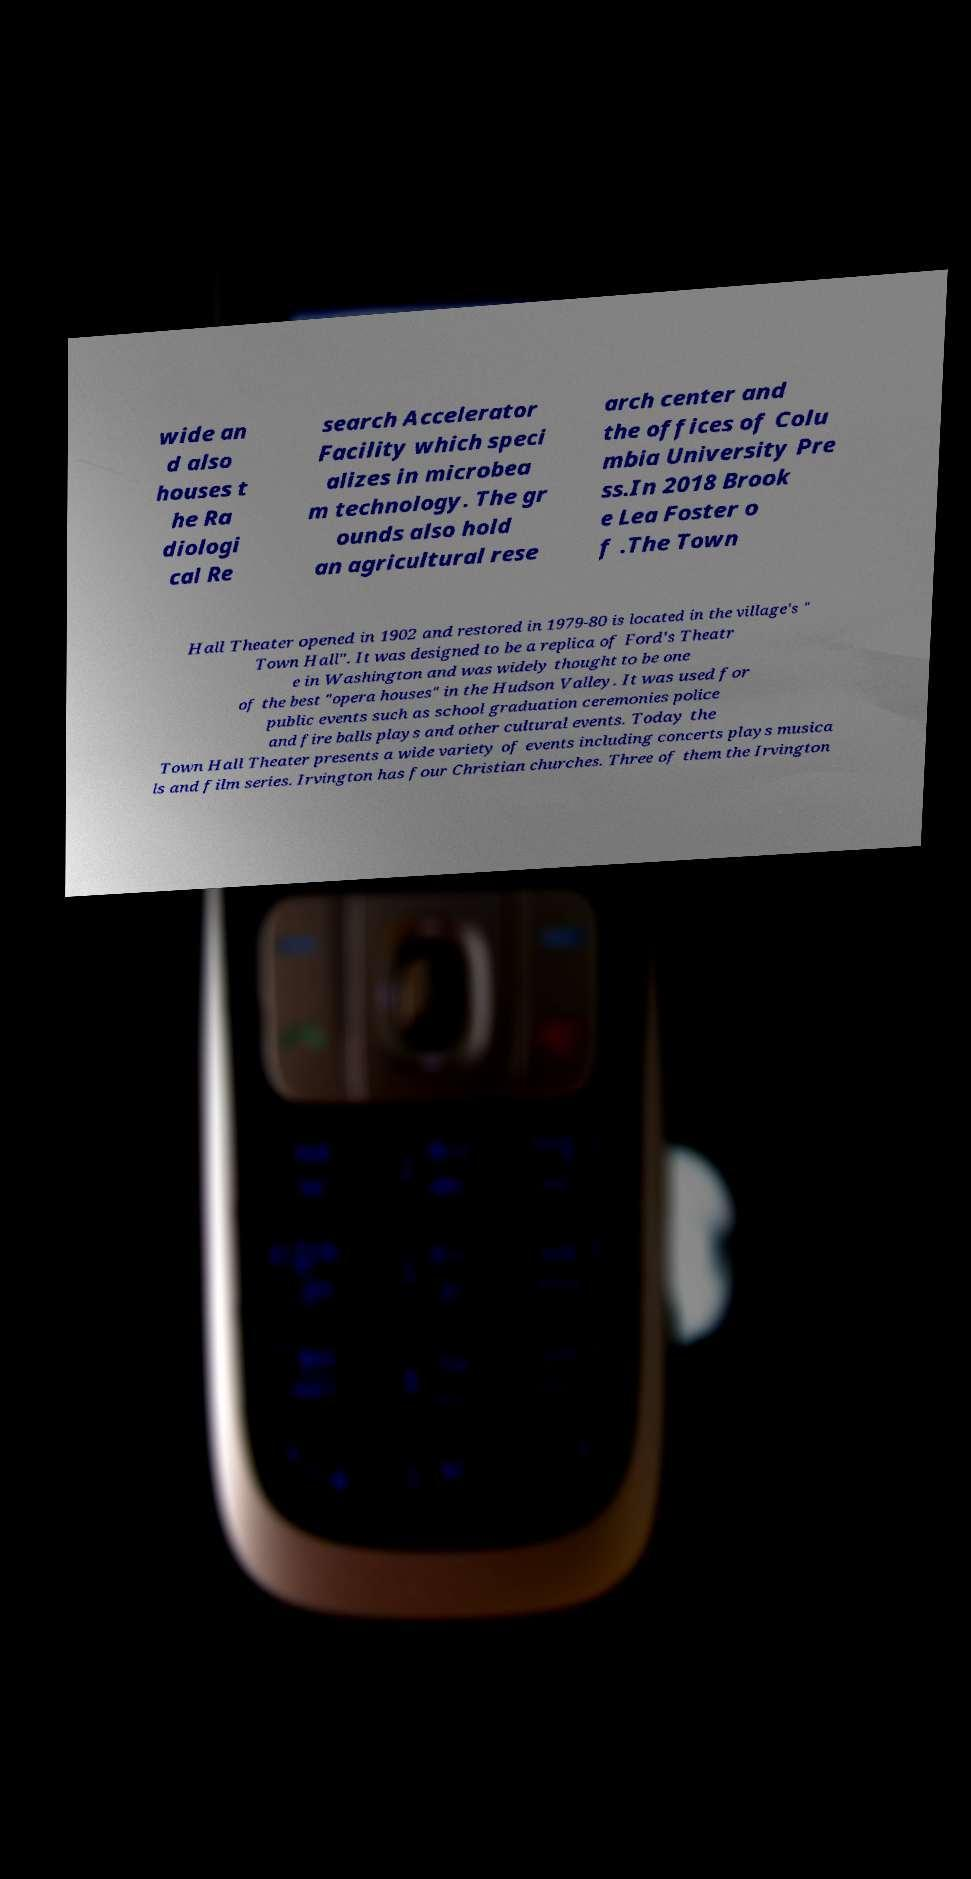Can you read and provide the text displayed in the image?This photo seems to have some interesting text. Can you extract and type it out for me? wide an d also houses t he Ra diologi cal Re search Accelerator Facility which speci alizes in microbea m technology. The gr ounds also hold an agricultural rese arch center and the offices of Colu mbia University Pre ss.In 2018 Brook e Lea Foster o f .The Town Hall Theater opened in 1902 and restored in 1979-80 is located in the village's " Town Hall". It was designed to be a replica of Ford's Theatr e in Washington and was widely thought to be one of the best "opera houses" in the Hudson Valley. It was used for public events such as school graduation ceremonies police and fire balls plays and other cultural events. Today the Town Hall Theater presents a wide variety of events including concerts plays musica ls and film series. Irvington has four Christian churches. Three of them the Irvington 